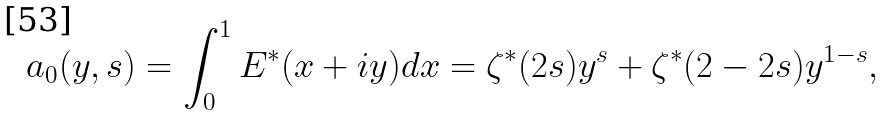<formula> <loc_0><loc_0><loc_500><loc_500>a _ { 0 } ( y , s ) = \int _ { 0 } ^ { 1 } E ^ { * } ( x + i y ) d x = \zeta ^ { * } ( 2 s ) y ^ { s } + \zeta ^ { * } ( 2 - 2 s ) y ^ { 1 - s } ,</formula> 